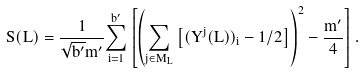<formula> <loc_0><loc_0><loc_500><loc_500>S ( L ) = \frac { 1 } { \sqrt { b ^ { \prime } } m ^ { \prime } } \underset { i = 1 } { \overset { b ^ { \prime } } { \sum } } \left [ \left ( \underset { j \in M _ { L } } { \sum } \left [ ( Y ^ { j } ( L ) ) _ { i } - 1 / 2 \right ] \right ) ^ { 2 } - \frac { m ^ { \prime } } { 4 } \right ] .</formula> 